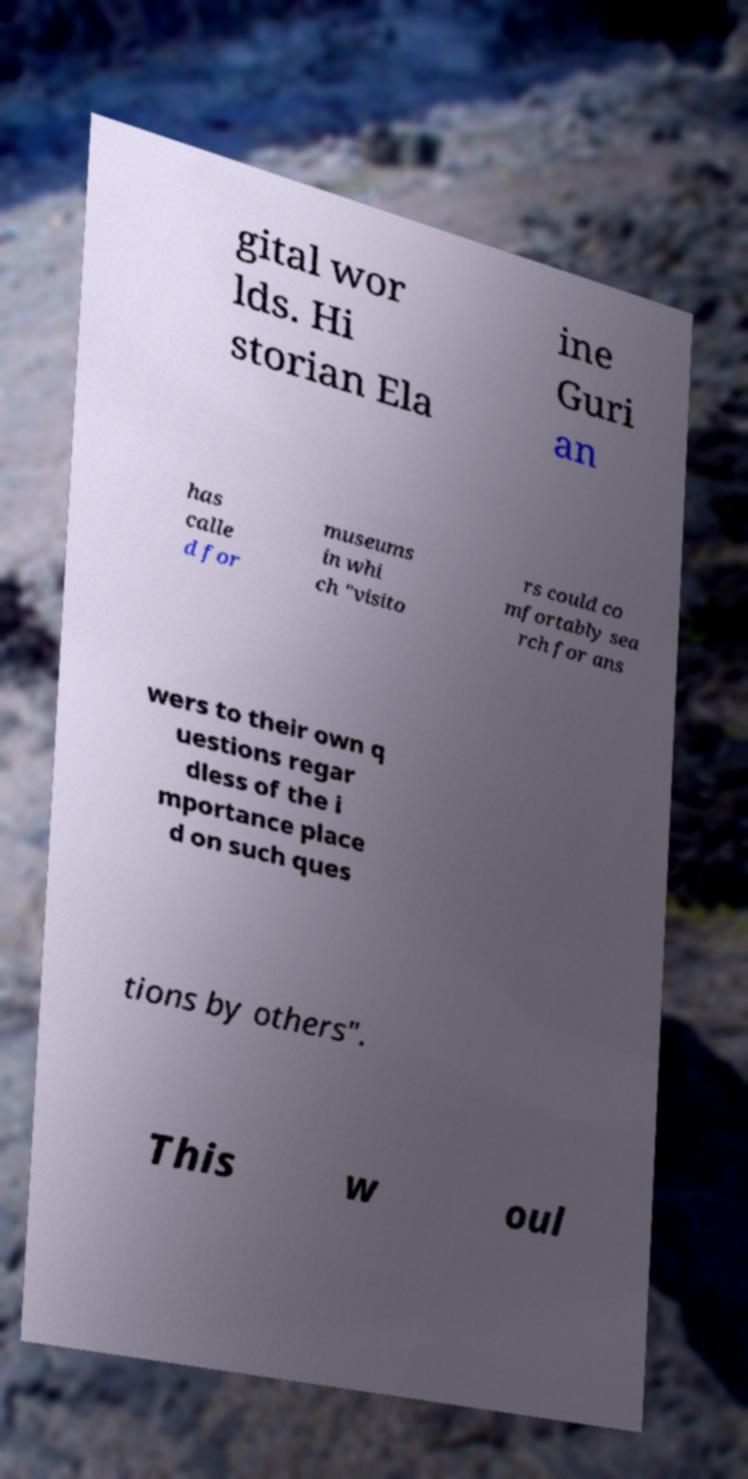Could you assist in decoding the text presented in this image and type it out clearly? gital wor lds. Hi storian Ela ine Guri an has calle d for museums in whi ch "visito rs could co mfortably sea rch for ans wers to their own q uestions regar dless of the i mportance place d on such ques tions by others". This w oul 